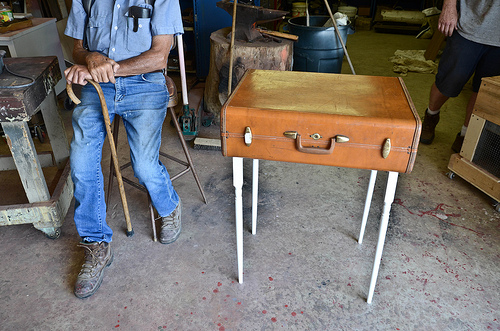<image>
Can you confirm if the suitcase is to the left of the floor? No. The suitcase is not to the left of the floor. From this viewpoint, they have a different horizontal relationship. Where is the man in relation to the cane? Is it to the right of the cane? No. The man is not to the right of the cane. The horizontal positioning shows a different relationship. Where is the suitcase in relation to the floor? Is it above the floor? Yes. The suitcase is positioned above the floor in the vertical space, higher up in the scene. 